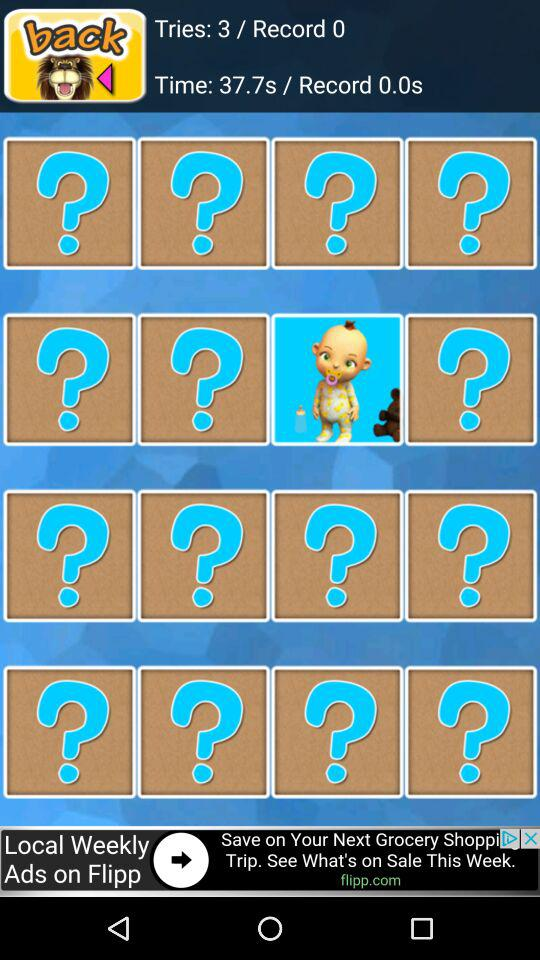What is the record?
When the provided information is insufficient, respond with <no answer>. <no answer> 